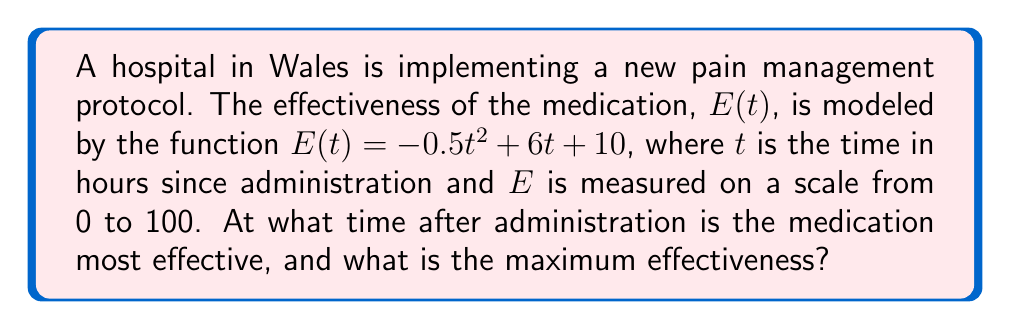Help me with this question. To find the optimal dosage rate, we need to determine when the effectiveness function reaches its maximum value.

1. The effectiveness function is given by:
   $E(t) = -0.5t^2 + 6t + 10$

2. To find the maximum, we need to find the critical point where the derivative equals zero:
   $\frac{dE}{dt} = -t + 6$

3. Set the derivative to zero and solve for $t$:
   $-t + 6 = 0$
   $t = 6$

4. To confirm this is a maximum (not a minimum), check the second derivative:
   $\frac{d^2E}{dt^2} = -1$ (always negative, confirming a maximum)

5. The time of maximum effectiveness is 6 hours after administration.

6. To find the maximum effectiveness, substitute $t = 6$ into the original function:
   $E(6) = -0.5(6)^2 + 6(6) + 10$
   $E(6) = -18 + 36 + 10 = 28$

Therefore, the medication is most effective 6 hours after administration, with a maximum effectiveness of 28 on the given scale.
Answer: 6 hours; 28 